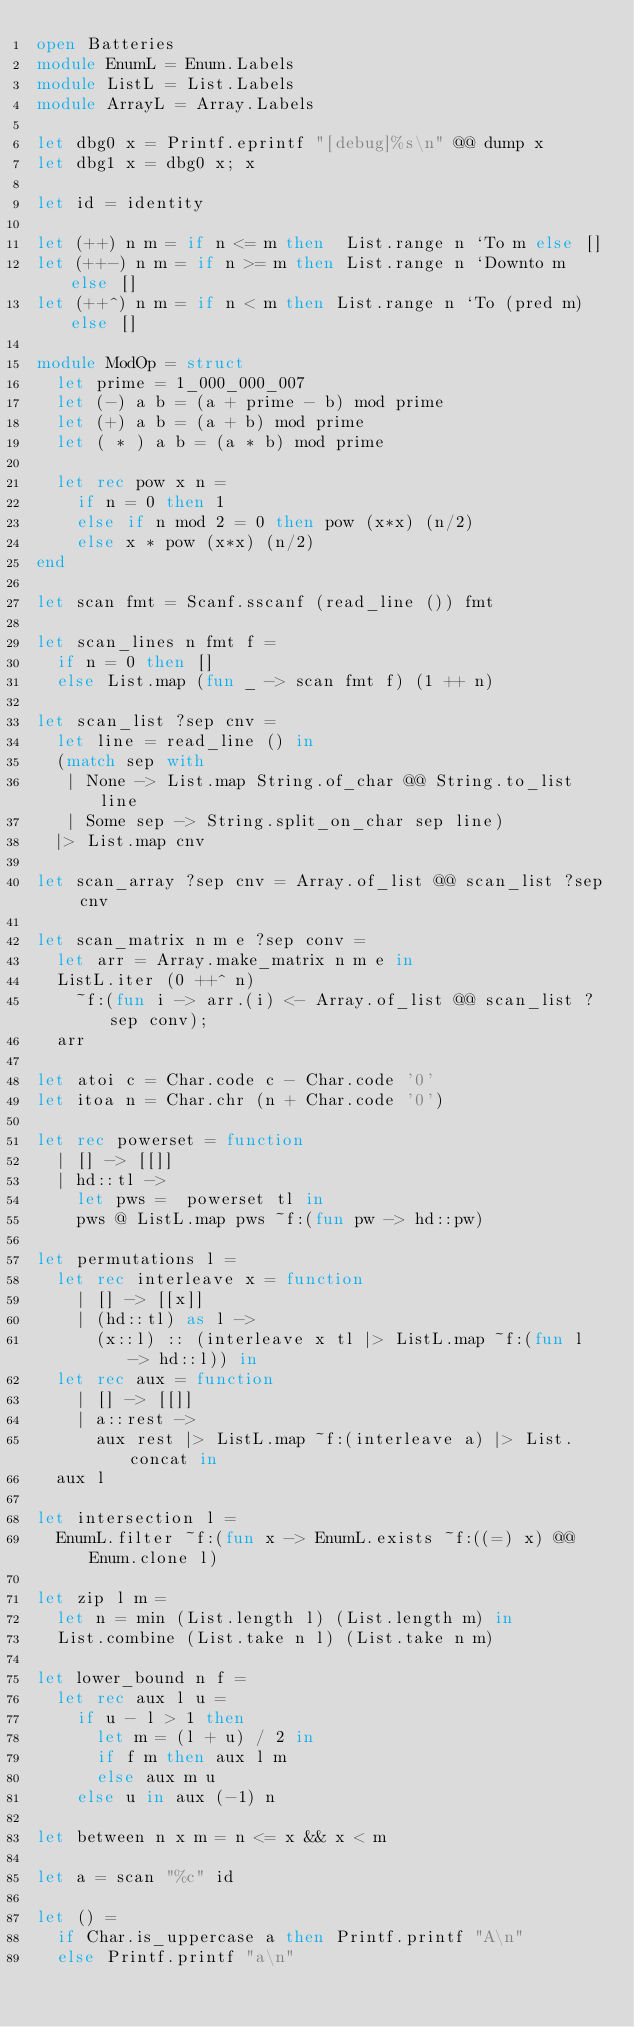<code> <loc_0><loc_0><loc_500><loc_500><_OCaml_>open Batteries
module EnumL = Enum.Labels
module ListL = List.Labels
module ArrayL = Array.Labels

let dbg0 x = Printf.eprintf "[debug]%s\n" @@ dump x
let dbg1 x = dbg0 x; x

let id = identity

let (++) n m = if n <= m then  List.range n `To m else []
let (++-) n m = if n >= m then List.range n `Downto m else []
let (++^) n m = if n < m then List.range n `To (pred m) else []

module ModOp = struct
  let prime = 1_000_000_007
  let (-) a b = (a + prime - b) mod prime
  let (+) a b = (a + b) mod prime
  let ( * ) a b = (a * b) mod prime

  let rec pow x n =
    if n = 0 then 1
    else if n mod 2 = 0 then pow (x*x) (n/2)
    else x * pow (x*x) (n/2)
end

let scan fmt = Scanf.sscanf (read_line ()) fmt

let scan_lines n fmt f =
  if n = 0 then []
  else List.map (fun _ -> scan fmt f) (1 ++ n)

let scan_list ?sep cnv =
  let line = read_line () in
  (match sep with
   | None -> List.map String.of_char @@ String.to_list line
   | Some sep -> String.split_on_char sep line)
  |> List.map cnv

let scan_array ?sep cnv = Array.of_list @@ scan_list ?sep cnv

let scan_matrix n m e ?sep conv =
  let arr = Array.make_matrix n m e in
  ListL.iter (0 ++^ n)
    ~f:(fun i -> arr.(i) <- Array.of_list @@ scan_list ?sep conv);
  arr

let atoi c = Char.code c - Char.code '0'
let itoa n = Char.chr (n + Char.code '0')

let rec powerset = function
  | [] -> [[]]
  | hd::tl ->
    let pws =  powerset tl in
    pws @ ListL.map pws ~f:(fun pw -> hd::pw)

let permutations l =
  let rec interleave x = function
    | [] -> [[x]]
    | (hd::tl) as l ->
      (x::l) :: (interleave x tl |> ListL.map ~f:(fun l -> hd::l)) in
  let rec aux = function
    | [] -> [[]]
    | a::rest ->
      aux rest |> ListL.map ~f:(interleave a) |> List.concat in
  aux l

let intersection l =
  EnumL.filter ~f:(fun x -> EnumL.exists ~f:((=) x) @@ Enum.clone l)

let zip l m =
  let n = min (List.length l) (List.length m) in
  List.combine (List.take n l) (List.take n m)

let lower_bound n f =
  let rec aux l u =
    if u - l > 1 then
      let m = (l + u) / 2 in
      if f m then aux l m
      else aux m u
    else u in aux (-1) n

let between n x m = n <= x && x < m

let a = scan "%c" id

let () =
  if Char.is_uppercase a then Printf.printf "A\n"
  else Printf.printf "a\n"
</code> 